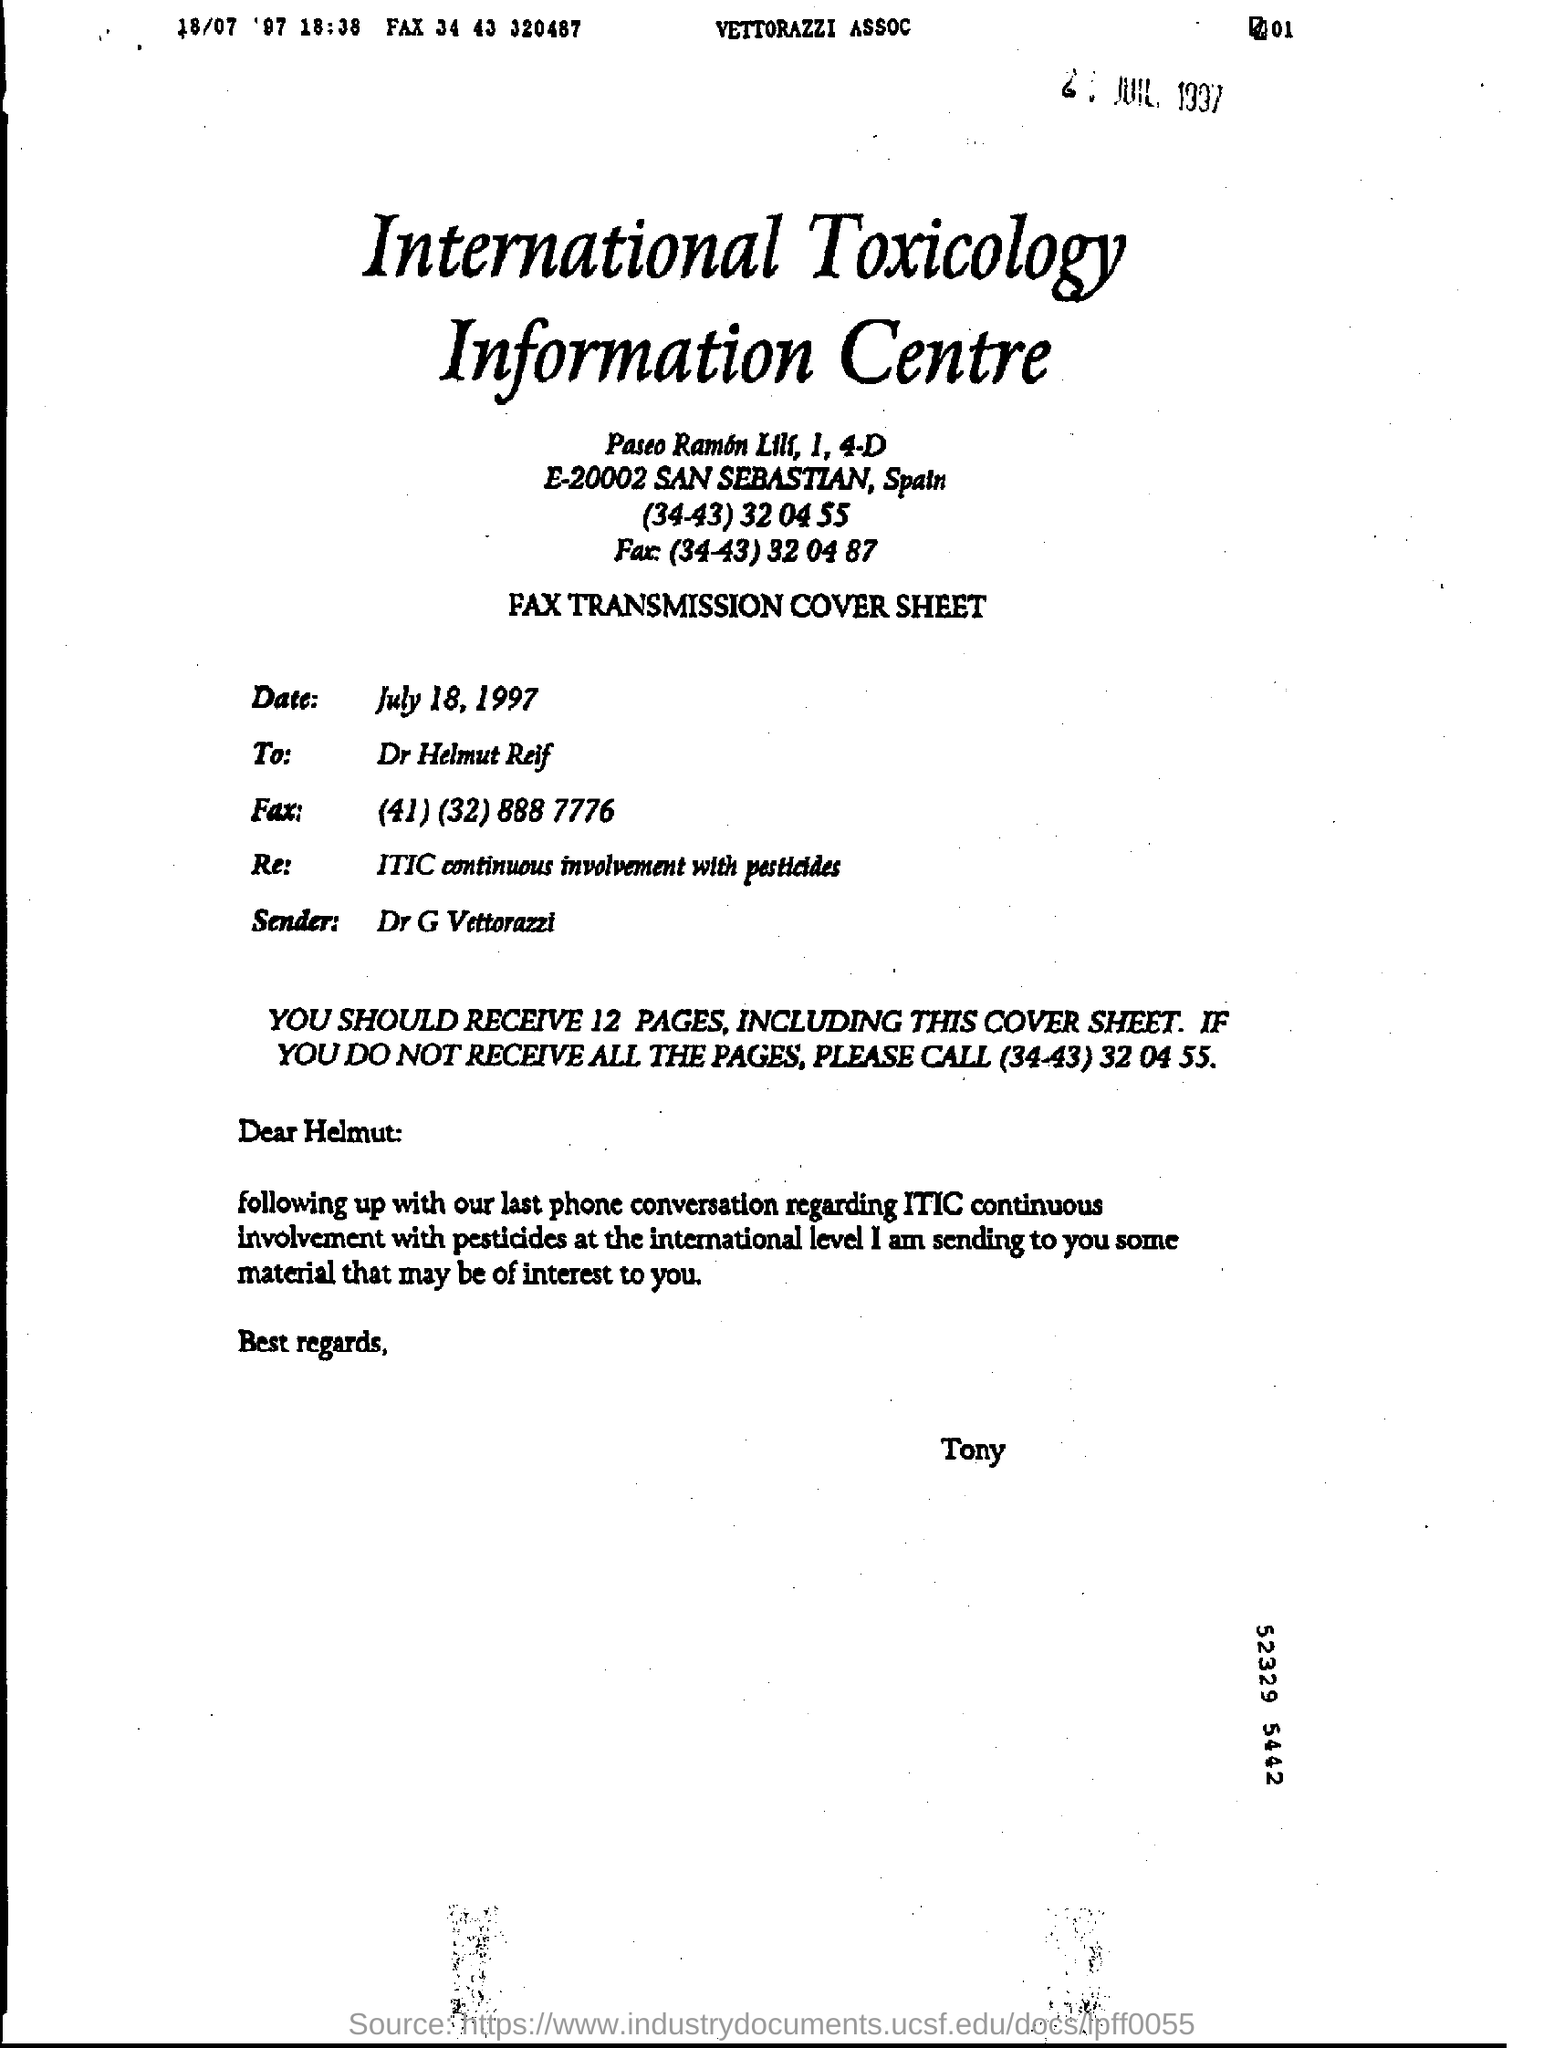What is the main heading of document ?
Your response must be concise. International Toxicology Information Centre. What is the Fax Number in the To Address  ?
Ensure brevity in your answer.  (41) (32) 888 7776. Who sent this ?
Your answer should be compact. Dr G Vettorazzi. Who is the recipient?
Make the answer very short. Dr Helmut Reif. What is the date mentioned in the document ?
Provide a succinct answer. July 18, 1997. 